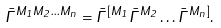Convert formula to latex. <formula><loc_0><loc_0><loc_500><loc_500>\bar { \Gamma } ^ { { M _ { 1 } } { M _ { 2 } } \dots { M _ { n } } } = \bar { \Gamma } ^ { [ M _ { 1 } } \bar { \Gamma } ^ { M _ { 2 } } \dots \bar { \Gamma } ^ { M _ { n } ] } .</formula> 